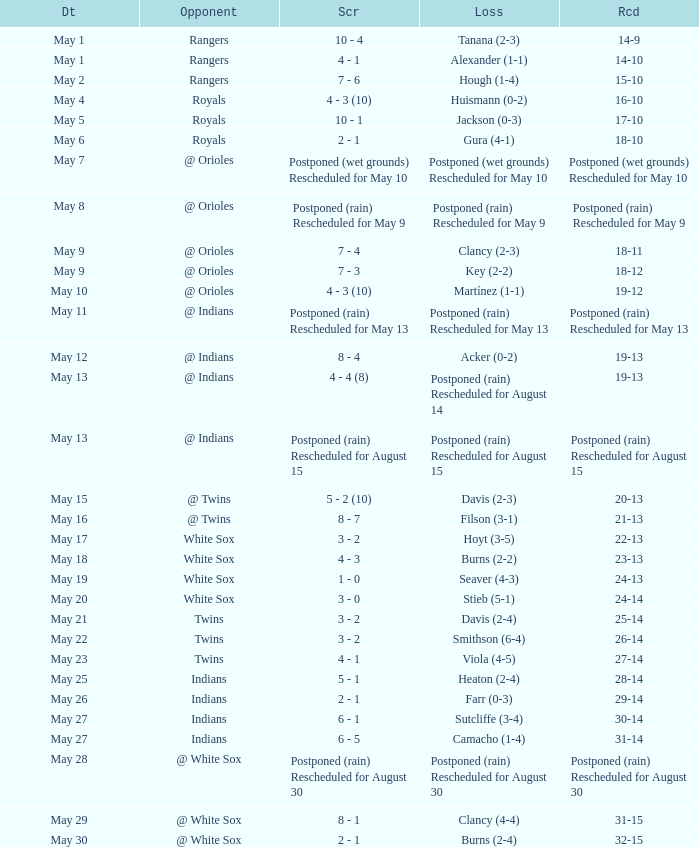What was date of the game when the record was 31-15? May 29. 